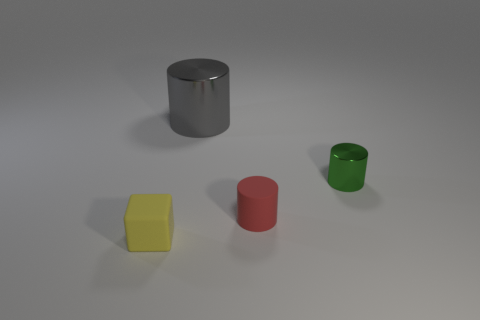What number of objects are both in front of the matte cylinder and on the right side of the large gray shiny cylinder?
Your answer should be very brief. 0. How many red things are big metallic cylinders or cylinders?
Your response must be concise. 1. Does the rubber thing that is to the left of the large metallic cylinder have the same color as the metal cylinder on the left side of the green metallic object?
Ensure brevity in your answer.  No. What color is the matte thing behind the object left of the metal cylinder behind the small shiny cylinder?
Your answer should be compact. Red. There is a small matte thing on the right side of the yellow matte cube; is there a rubber cube that is in front of it?
Offer a very short reply. Yes. Is the shape of the small object in front of the tiny red matte object the same as  the tiny metallic thing?
Offer a very short reply. No. Is there any other thing that is the same shape as the red matte object?
Offer a terse response. Yes. How many blocks are either yellow things or green metallic objects?
Offer a very short reply. 1. What number of tiny cubes are there?
Offer a terse response. 1. How big is the rubber object that is right of the matte thing left of the rubber cylinder?
Your answer should be compact. Small. 